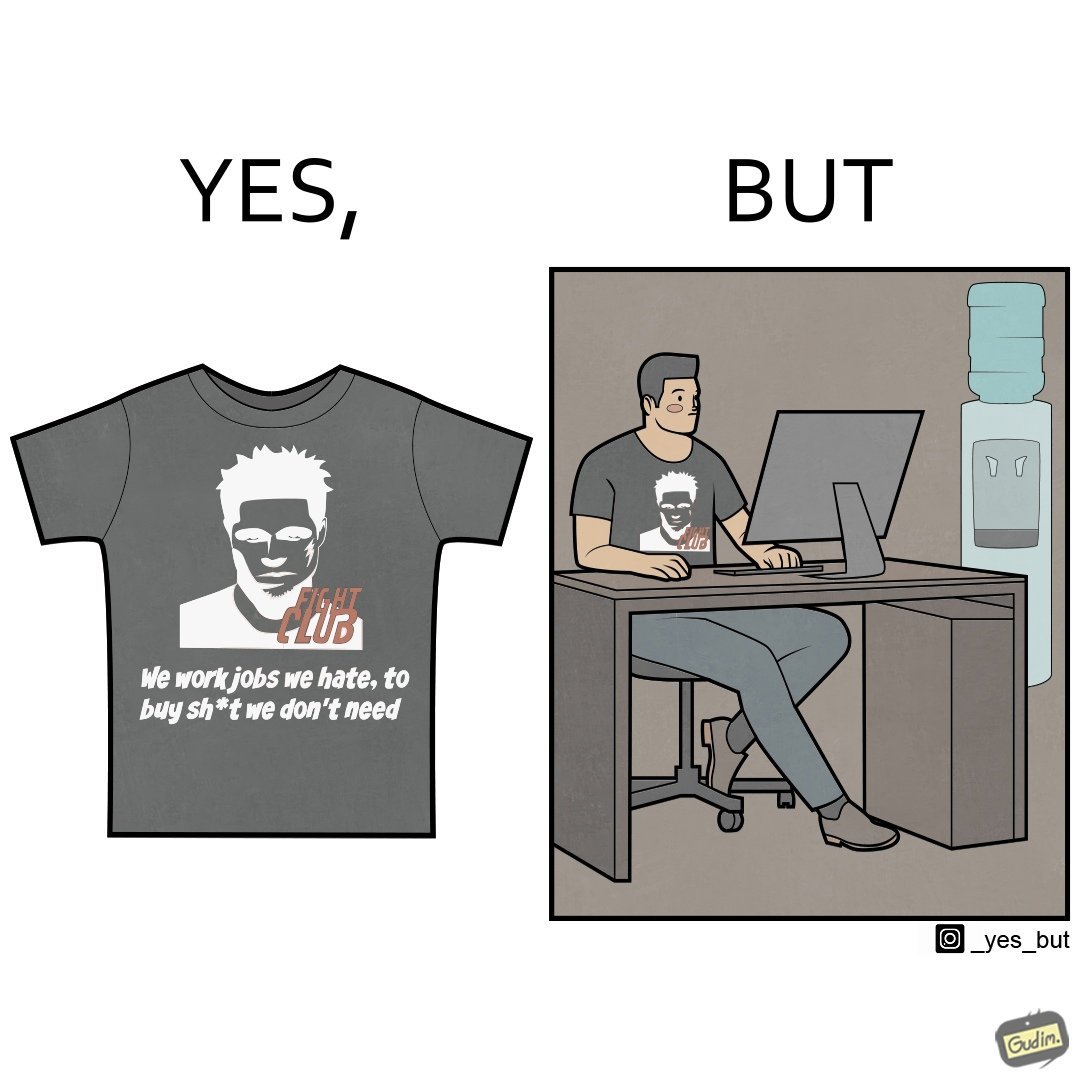Explain why this image is satirical. The image is ironical, as the t-shirt says "We work jobs we hate, to buy sh*t we don't need", which is a rebellious message against the construct of office jobs. However, the person wearing the t-shirt seems to be working in an office environment. Also, the t-shirt might have been bought using the money earned via the very same job. 